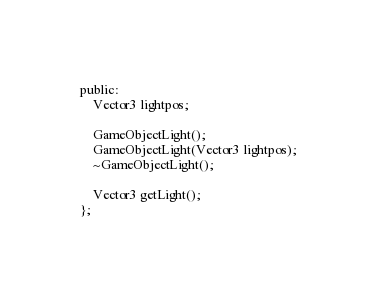<code> <loc_0><loc_0><loc_500><loc_500><_C_>public:
	Vector3 lightpos;

	GameObjectLight();
	GameObjectLight(Vector3 lightpos);
	~GameObjectLight();

	Vector3 getLight();
};</code> 